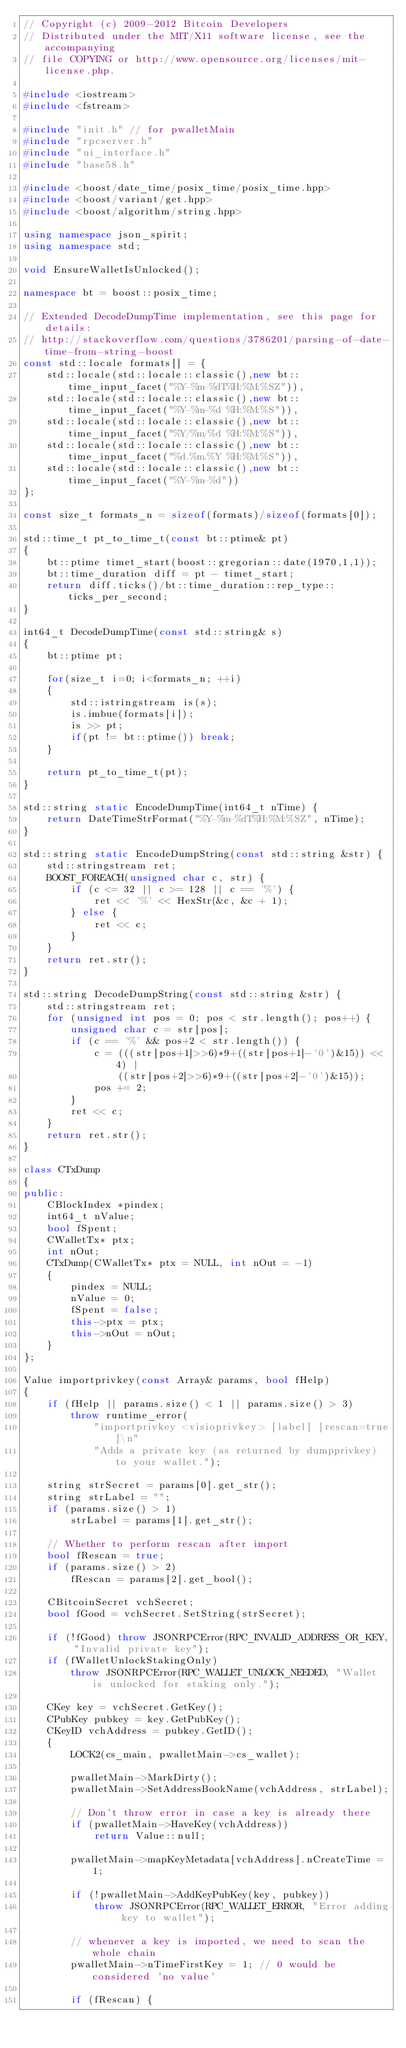Convert code to text. <code><loc_0><loc_0><loc_500><loc_500><_C++_>// Copyright (c) 2009-2012 Bitcoin Developers
// Distributed under the MIT/X11 software license, see the accompanying
// file COPYING or http://www.opensource.org/licenses/mit-license.php.

#include <iostream>
#include <fstream>

#include "init.h" // for pwalletMain
#include "rpcserver.h"
#include "ui_interface.h"
#include "base58.h"

#include <boost/date_time/posix_time/posix_time.hpp>
#include <boost/variant/get.hpp>
#include <boost/algorithm/string.hpp>

using namespace json_spirit;
using namespace std;

void EnsureWalletIsUnlocked();

namespace bt = boost::posix_time;

// Extended DecodeDumpTime implementation, see this page for details:
// http://stackoverflow.com/questions/3786201/parsing-of-date-time-from-string-boost
const std::locale formats[] = {
    std::locale(std::locale::classic(),new bt::time_input_facet("%Y-%m-%dT%H:%M:%SZ")),
    std::locale(std::locale::classic(),new bt::time_input_facet("%Y-%m-%d %H:%M:%S")),
    std::locale(std::locale::classic(),new bt::time_input_facet("%Y/%m/%d %H:%M:%S")),
    std::locale(std::locale::classic(),new bt::time_input_facet("%d.%m.%Y %H:%M:%S")),
    std::locale(std::locale::classic(),new bt::time_input_facet("%Y-%m-%d"))
};

const size_t formats_n = sizeof(formats)/sizeof(formats[0]);

std::time_t pt_to_time_t(const bt::ptime& pt)
{
    bt::ptime timet_start(boost::gregorian::date(1970,1,1));
    bt::time_duration diff = pt - timet_start;
    return diff.ticks()/bt::time_duration::rep_type::ticks_per_second;
}

int64_t DecodeDumpTime(const std::string& s)
{
    bt::ptime pt;

    for(size_t i=0; i<formats_n; ++i)
    {
        std::istringstream is(s);
        is.imbue(formats[i]);
        is >> pt;
        if(pt != bt::ptime()) break;
    }

    return pt_to_time_t(pt);
}

std::string static EncodeDumpTime(int64_t nTime) {
    return DateTimeStrFormat("%Y-%m-%dT%H:%M:%SZ", nTime);
}

std::string static EncodeDumpString(const std::string &str) {
    std::stringstream ret;
    BOOST_FOREACH(unsigned char c, str) {
        if (c <= 32 || c >= 128 || c == '%') {
            ret << '%' << HexStr(&c, &c + 1);
        } else {
            ret << c;
        }
    }
    return ret.str();
}

std::string DecodeDumpString(const std::string &str) {
    std::stringstream ret;
    for (unsigned int pos = 0; pos < str.length(); pos++) {
        unsigned char c = str[pos];
        if (c == '%' && pos+2 < str.length()) {
            c = (((str[pos+1]>>6)*9+((str[pos+1]-'0')&15)) << 4) | 
                ((str[pos+2]>>6)*9+((str[pos+2]-'0')&15));
            pos += 2;
        }
        ret << c;
    }
    return ret.str();
}

class CTxDump
{
public:
    CBlockIndex *pindex;
    int64_t nValue;
    bool fSpent;
    CWalletTx* ptx;
    int nOut;
    CTxDump(CWalletTx* ptx = NULL, int nOut = -1)
    {
        pindex = NULL;
        nValue = 0;
        fSpent = false;
        this->ptx = ptx;
        this->nOut = nOut;
    }
};

Value importprivkey(const Array& params, bool fHelp)
{
    if (fHelp || params.size() < 1 || params.size() > 3)
        throw runtime_error(
            "importprivkey <visioprivkey> [label] [rescan=true]\n"
            "Adds a private key (as returned by dumpprivkey) to your wallet.");

    string strSecret = params[0].get_str();
    string strLabel = "";
    if (params.size() > 1)
        strLabel = params[1].get_str();

    // Whether to perform rescan after import
    bool fRescan = true;
    if (params.size() > 2)
        fRescan = params[2].get_bool();

    CBitcoinSecret vchSecret;
    bool fGood = vchSecret.SetString(strSecret);

    if (!fGood) throw JSONRPCError(RPC_INVALID_ADDRESS_OR_KEY, "Invalid private key");
    if (fWalletUnlockStakingOnly)
        throw JSONRPCError(RPC_WALLET_UNLOCK_NEEDED, "Wallet is unlocked for staking only.");

    CKey key = vchSecret.GetKey();
    CPubKey pubkey = key.GetPubKey();
    CKeyID vchAddress = pubkey.GetID();
    {
        LOCK2(cs_main, pwalletMain->cs_wallet);

        pwalletMain->MarkDirty();
        pwalletMain->SetAddressBookName(vchAddress, strLabel);

        // Don't throw error in case a key is already there
        if (pwalletMain->HaveKey(vchAddress))
            return Value::null;

        pwalletMain->mapKeyMetadata[vchAddress].nCreateTime = 1;

        if (!pwalletMain->AddKeyPubKey(key, pubkey))
            throw JSONRPCError(RPC_WALLET_ERROR, "Error adding key to wallet");

        // whenever a key is imported, we need to scan the whole chain
        pwalletMain->nTimeFirstKey = 1; // 0 would be considered 'no value'

        if (fRescan) {</code> 